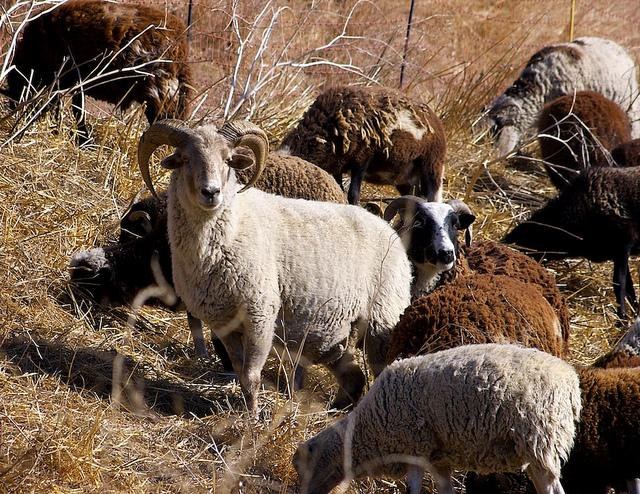Why are the sheep difference colors?

Choices:
A) breed
B) dirty
C) gender
D) spray-painted breed 